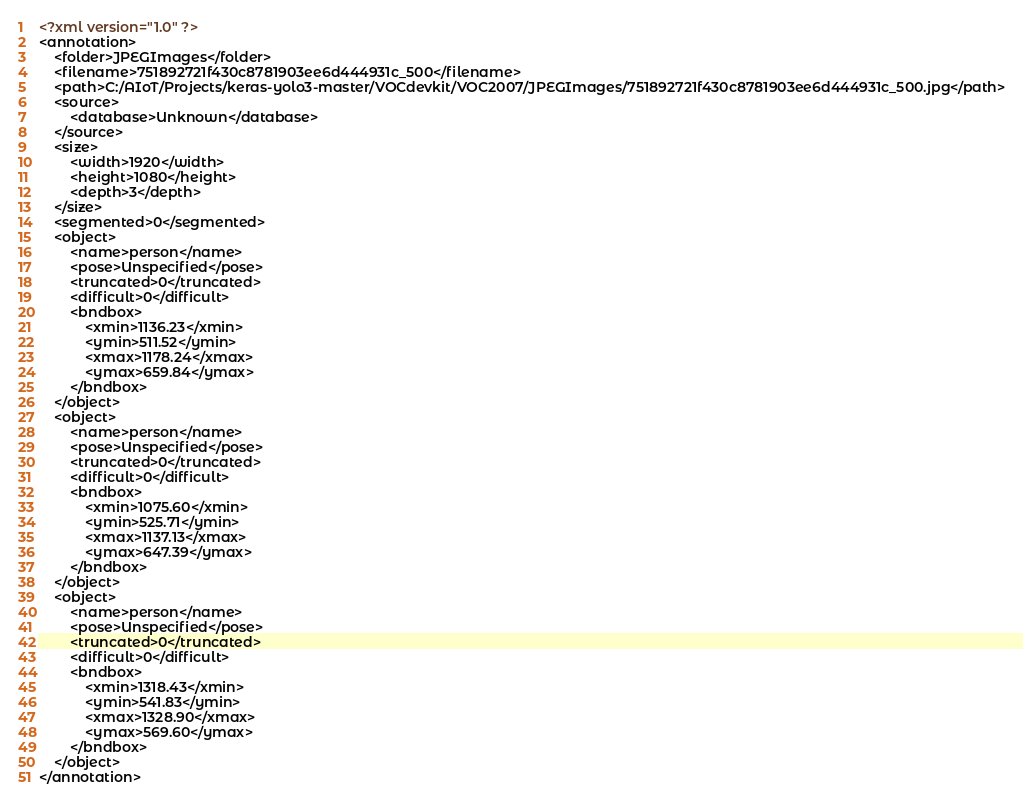<code> <loc_0><loc_0><loc_500><loc_500><_XML_><?xml version="1.0" ?>
<annotation>
	<folder>JPEGImages</folder>
	<filename>751892721f430c8781903ee6d444931c_500</filename>
	<path>C:/AIoT/Projects/keras-yolo3-master/VOCdevkit/VOC2007/JPEGImages/751892721f430c8781903ee6d444931c_500.jpg</path>
	<source>
		<database>Unknown</database>
	</source>
	<size>
		<width>1920</width>
		<height>1080</height>
		<depth>3</depth>
	</size>
	<segmented>0</segmented>
	<object>
		<name>person</name>
		<pose>Unspecified</pose>
		<truncated>0</truncated>
		<difficult>0</difficult>
		<bndbox>
			<xmin>1136.23</xmin>
			<ymin>511.52</ymin>
			<xmax>1178.24</xmax>
			<ymax>659.84</ymax>
		</bndbox>
	</object>
	<object>
		<name>person</name>
		<pose>Unspecified</pose>
		<truncated>0</truncated>
		<difficult>0</difficult>
		<bndbox>
			<xmin>1075.60</xmin>
			<ymin>525.71</ymin>
			<xmax>1137.13</xmax>
			<ymax>647.39</ymax>
		</bndbox>
	</object>
	<object>
		<name>person</name>
		<pose>Unspecified</pose>
		<truncated>0</truncated>
		<difficult>0</difficult>
		<bndbox>
			<xmin>1318.43</xmin>
			<ymin>541.83</ymin>
			<xmax>1328.90</xmax>
			<ymax>569.60</ymax>
		</bndbox>
	</object>
</annotation>
</code> 